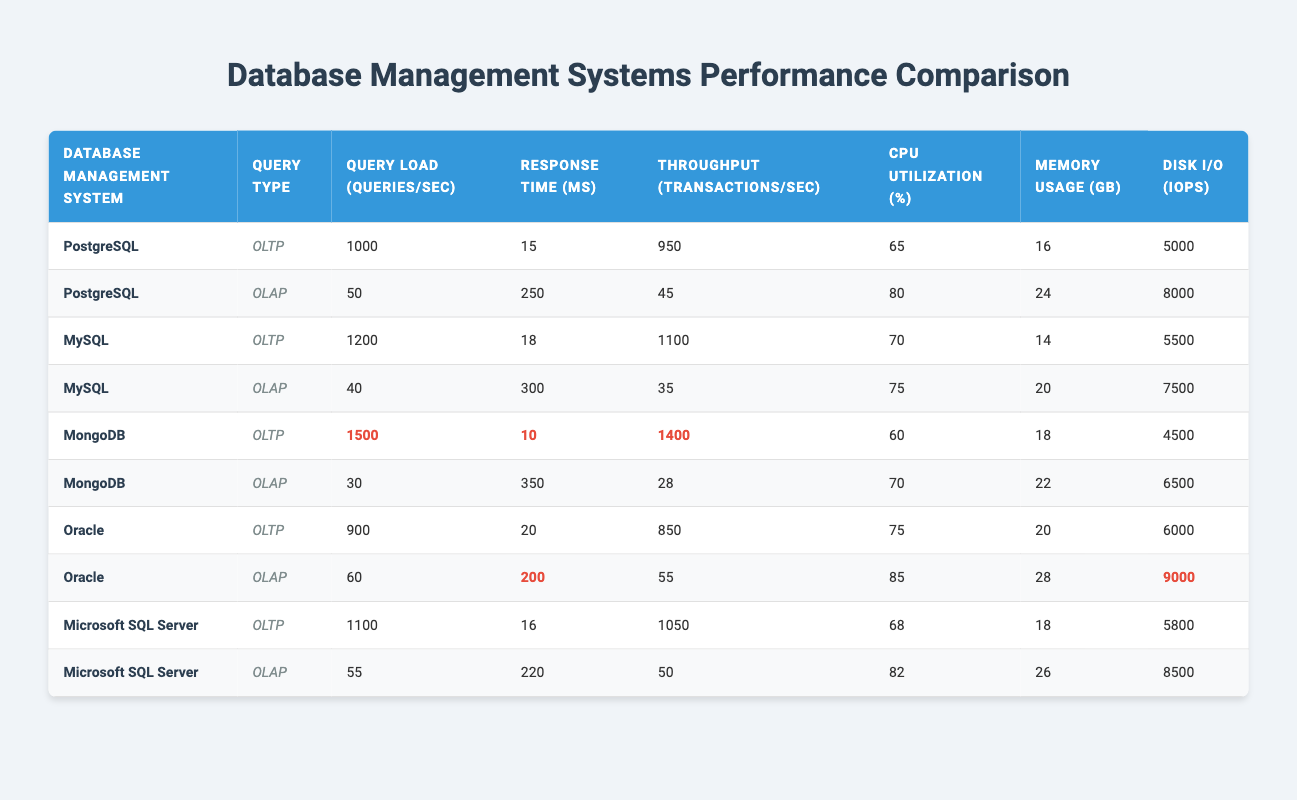What is the response time for MongoDB under OLTP query type? The table shows that the response time for MongoDB under the OLTP query type is recorded as 10 ms.
Answer: 10 ms What is the average CPU utilization across all database management systems for OLTP query type? For OLTP: PostgreSQL (65), MySQL (70), MongoDB (60), Oracle (75), Microsoft SQL Server (68). The sum is 65 + 70 + 60 + 75 + 68 = 338, and there are 5 databases, so the average CPU utilization is 338/5 = 67.6%.
Answer: 67.6% Is it true that MySQL has the highest throughput for OLTP query type? The throughput for MySQL in OLTP is 1100, while PostgreSQL’s is 950, MongoDB’s is 1400, Oracle’s is 850, and Microsoft SQL Server’s is 1050. Therefore, MongoDB has the highest throughput among them.
Answer: No Which database has the lowest disk I/O for OLTP query type? The IOPS for OLTP shows: PostgreSQL (5000), MySQL (5500), MongoDB (4500), Oracle (6000), and Microsoft SQL Server (5800). MongoDB has the lowest at 4500 IOPS.
Answer: MongoDB What is the difference in memory usage between the highest and lowest OLAP memory usage among the databases? The OLAP memory usage shows: PostgreSQL (24), MySQL (20), MongoDB (22), Oracle (28), and Microsoft SQL Server (26). The highest is 28 (Oracle), and the lowest is 20 (MySQL), so the difference is 28 - 20 = 8 GB.
Answer: 8 GB What is the query load for Oracle under OLAP query type? The table indicates that the query load for Oracle under the OLAP query type is 60 queries/sec.
Answer: 60 queries/sec Is the response time for PostgreSQL under OLAP query type lower than 300 ms? The response time for PostgreSQL under OLAP is 250 ms, which is indeed lower than 300 ms.
Answer: Yes Which database management system under OLAP has the highest disk I/O? The disk I/O for OLAP shows: PostgreSQL (8000), MySQL (7500), MongoDB (6500), Oracle (9000), and Microsoft SQL Server (8500). Oracle has the highest at 9000 IOPS.
Answer: Oracle 